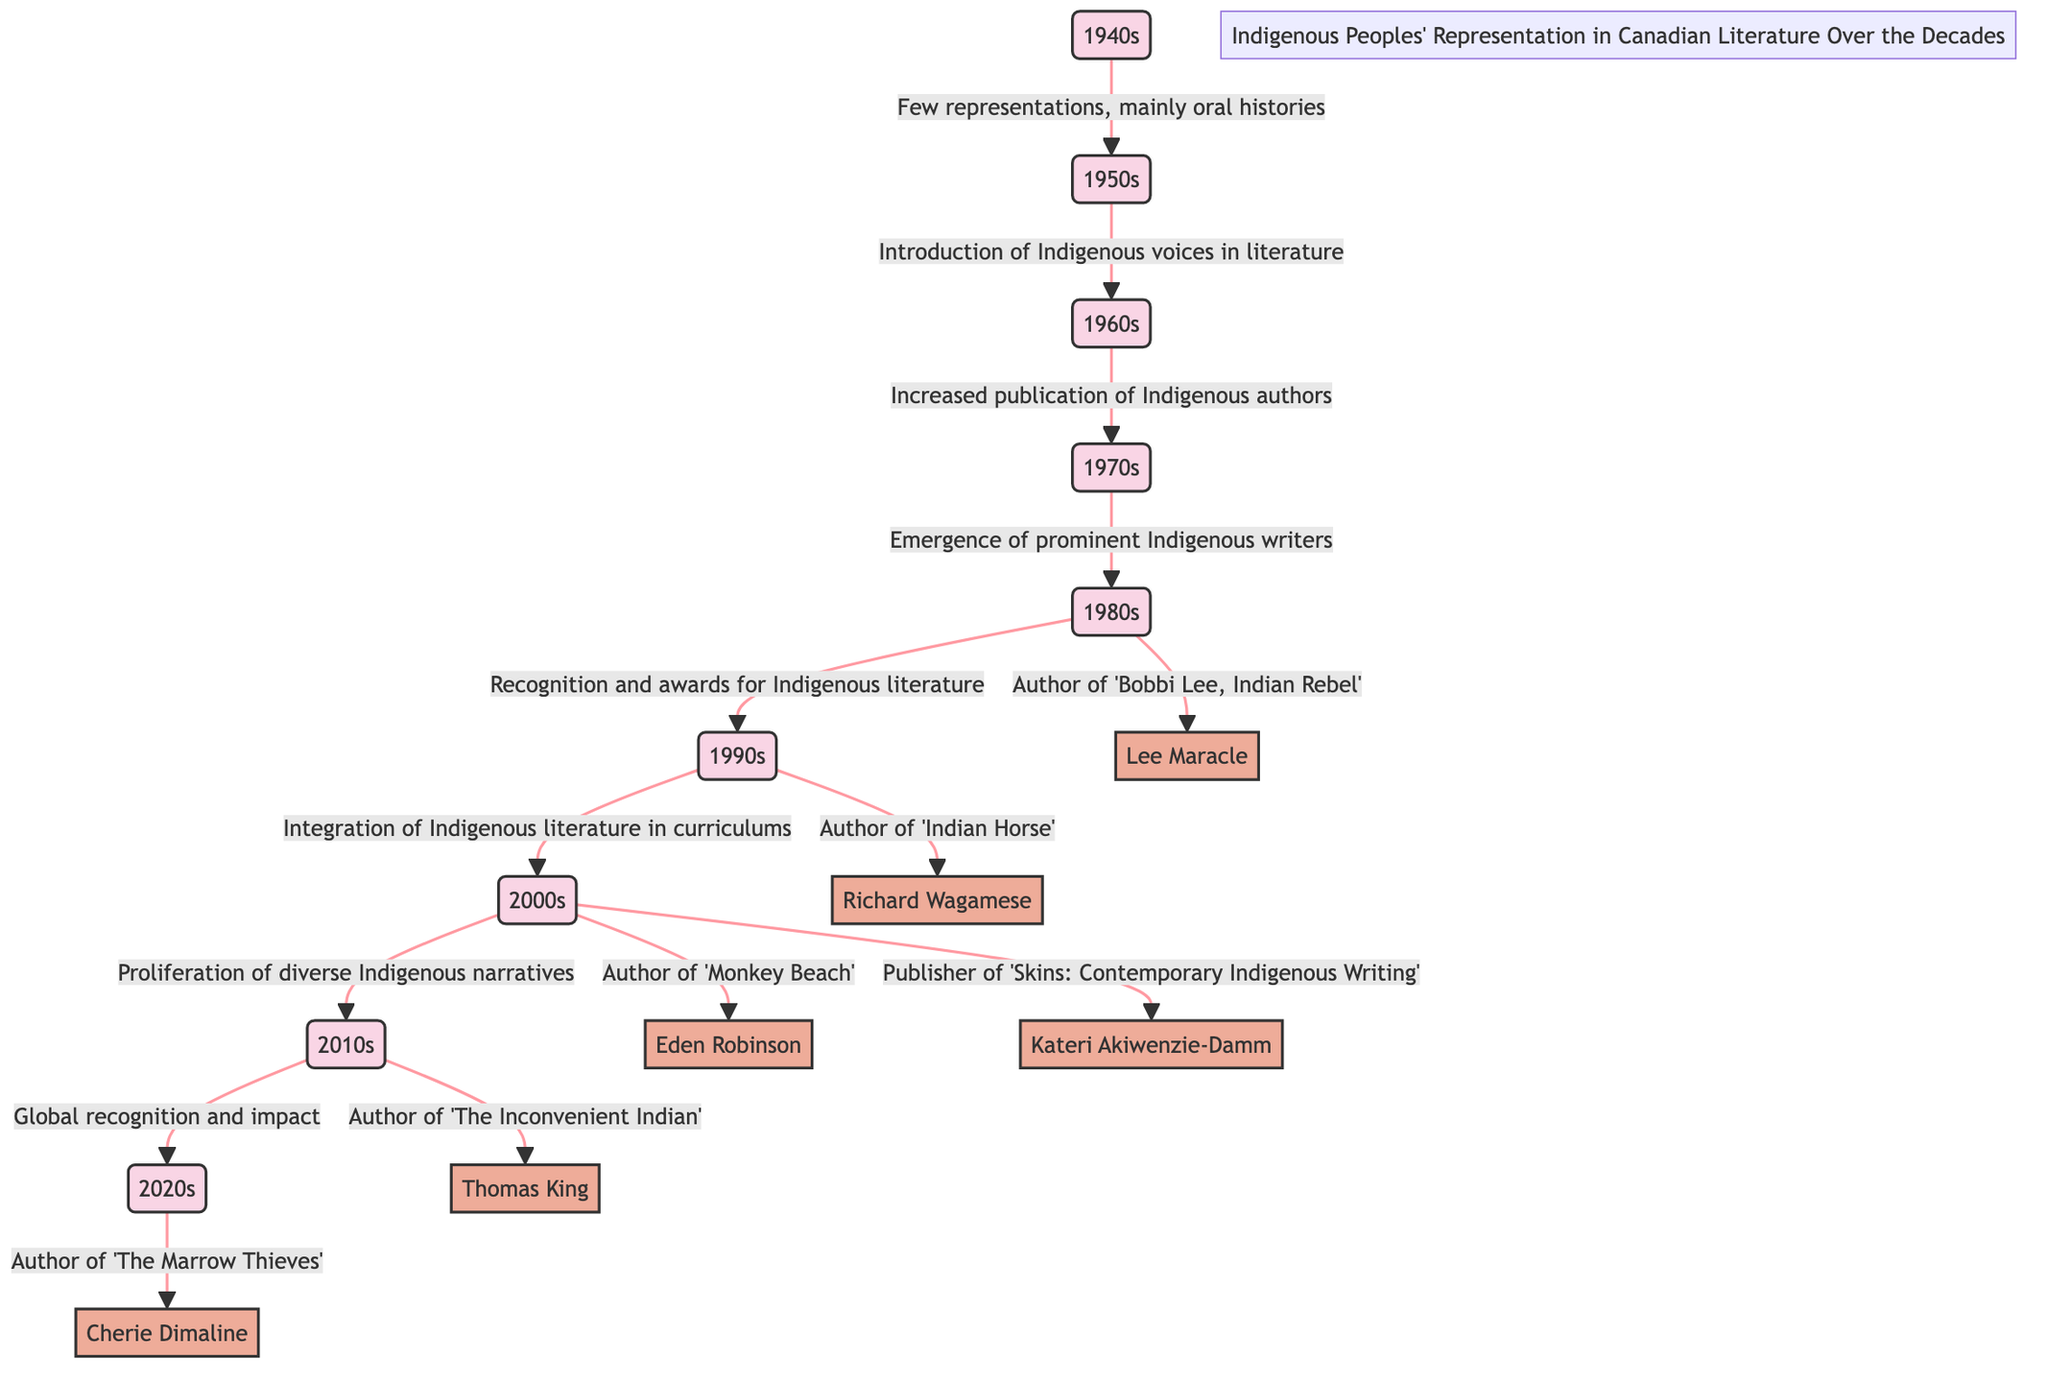What decade shows the emergence of prominent Indigenous writers? The diagram indicates that the 1970s is the decade where there was an emergence of prominent Indigenous writers. This is directly stated in the flow from the 1960s to the 1970s, which captures this development distinctly.
Answer: 1970s Who is the author of 'The Inconvenient Indian'? From the diagram, it is clear that Thomas King is the author related to 'The Inconvenient Indian'. This is shown in the flow that leads to the 2010s, where his contribution is noted explicitly.
Answer: Thomas King How many decades are represented in the diagram? By counting each decade listed in the diagram, we see there are a total of 8 decades mentioned: the 1940s through the 2020s. This can be determined by following the flow from the first decade to the last.
Answer: 8 What representation was noted for the 1980s? The diagram specifies that the 1980s include the recognition and awards for Indigenous literature. This information is provided directly in the flow from the 1970s to the 1980s.
Answer: Recognition and awards for Indigenous literature What shift occurred in the 2000s regarding Indigenous literature? The 2000s is characterized by a proliferation of diverse Indigenous narratives. This transition is documented in the progression from the 1990s to the 2000s, indicating a shift in the representation and type of literature produced.
Answer: Proliferation of diverse Indigenous narratives Which decade saw the integration of Indigenous literature in curricula? According to the diagram, the integration of Indigenous literature into curriculums occurred in the 2000s. This is directly linked in the transition from the 1990s to the 2000s, where this integration is specifically mentioned.
Answer: 2000s Who authored 'Indian Horse'? The diagram indicates Richard Wagamese as the author of 'Indian Horse'. This is noted specifically in the flow leading into the 1990s, identifying his contribution to literature in that era.
Answer: Richard Wagamese Which individual played a role in publishing 'Skins: Contemporary Indigenous Writing'? Kateri Akiwenzie-Damm is recognized in the diagram for publishing 'Skins: Contemporary Indigenous Writing'. This information is positioned in the flow for the 2000s, highlighting her contribution in that decade.
Answer: Kateri Akiwenzie-Damm 